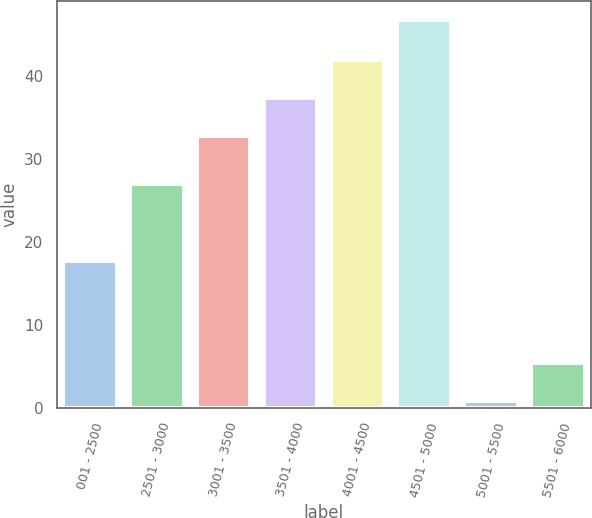Convert chart to OTSL. <chart><loc_0><loc_0><loc_500><loc_500><bar_chart><fcel>001 - 2500<fcel>2501 - 3000<fcel>3001 - 3500<fcel>3501 - 4000<fcel>4001 - 4500<fcel>4501 - 5000<fcel>5001 - 5500<fcel>5501 - 6000<nl><fcel>17.66<fcel>26.92<fcel>32.73<fcel>37.31<fcel>41.92<fcel>46.64<fcel>0.81<fcel>5.39<nl></chart> 